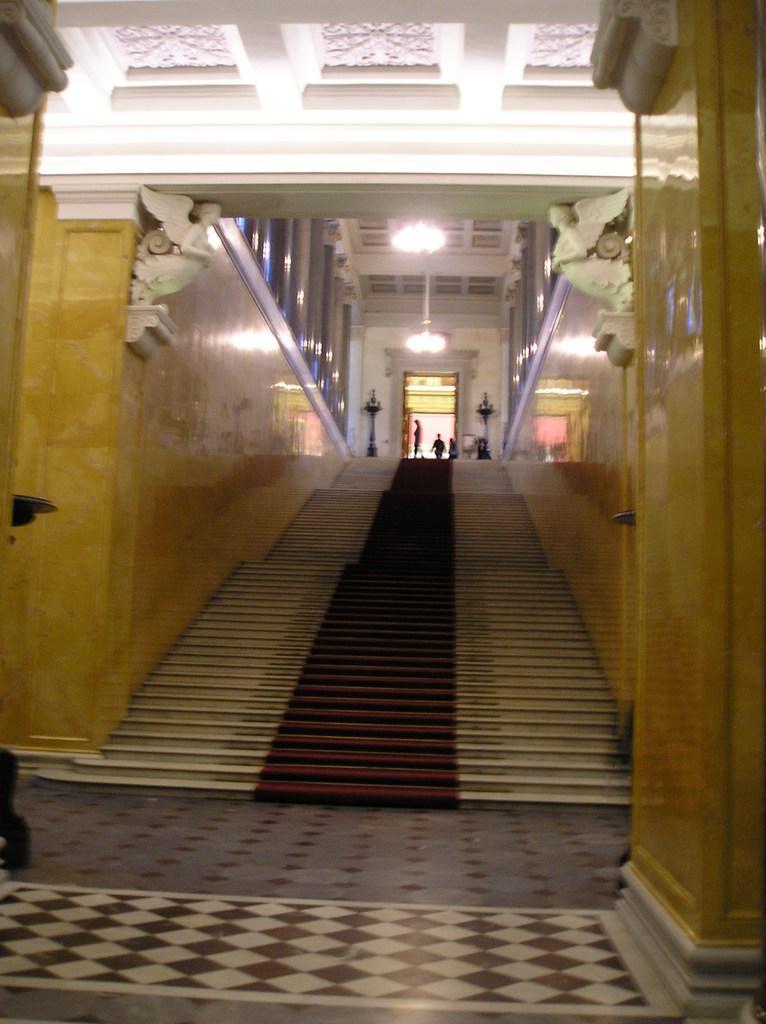In one or two sentences, can you explain what this image depicts? In the foreground of this image, there is floor and two pillars on either side of the image. In the background, there are stairs, pillars, lights to the ceiling and an entrance having two objects on the either side. 